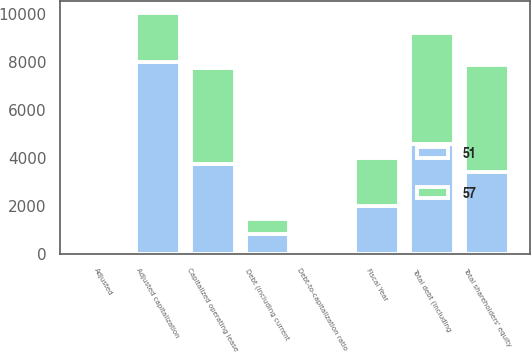Convert chart to OTSL. <chart><loc_0><loc_0><loc_500><loc_500><stacked_bar_chart><ecel><fcel>Fiscal Year<fcel>Debt (including current<fcel>Capitalized operating lease<fcel>Total debt (including<fcel>Total shareholders' equity<fcel>Adjusted capitalization<fcel>Debt-to-capitalization ratio<fcel>Adjusted<nl><fcel>57<fcel>2005<fcel>600<fcel>4007<fcel>4607<fcel>4449<fcel>2005<fcel>12<fcel>51<nl><fcel>51<fcel>2004<fcel>850<fcel>3746<fcel>4596<fcel>3422<fcel>8018<fcel>20<fcel>57<nl></chart> 